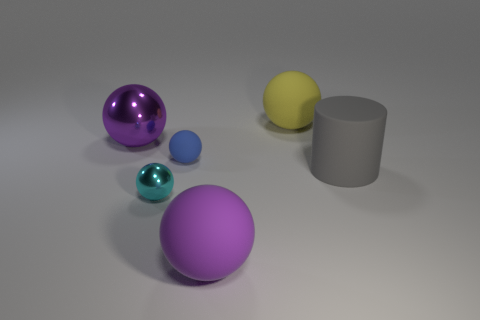Subtract all blue cylinders. How many purple balls are left? 2 Subtract all blue rubber spheres. How many spheres are left? 4 Add 4 matte balls. How many objects exist? 10 Subtract all cyan balls. How many balls are left? 4 Subtract 1 spheres. How many spheres are left? 4 Subtract all spheres. How many objects are left? 1 Subtract 0 red balls. How many objects are left? 6 Subtract all red cylinders. Subtract all yellow cubes. How many cylinders are left? 1 Subtract all yellow rubber cubes. Subtract all big spheres. How many objects are left? 3 Add 6 large gray objects. How many large gray objects are left? 7 